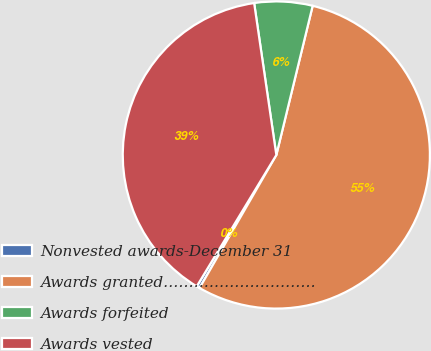<chart> <loc_0><loc_0><loc_500><loc_500><pie_chart><fcel>Nonvested awards-December 31<fcel>Awards granted…………………………<fcel>Awards forfeited<fcel>Awards vested<nl><fcel>0.34%<fcel>54.53%<fcel>6.11%<fcel>39.02%<nl></chart> 